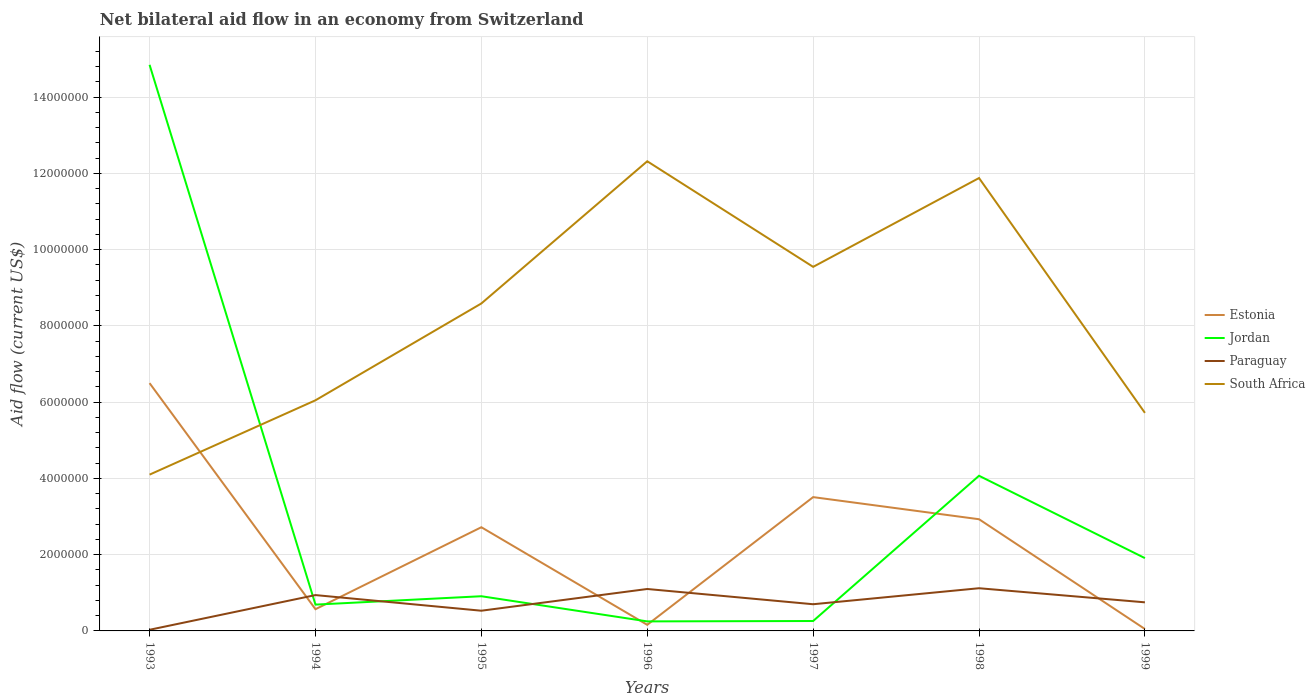Across all years, what is the maximum net bilateral aid flow in South Africa?
Ensure brevity in your answer.  4.10e+06. In which year was the net bilateral aid flow in South Africa maximum?
Give a very brief answer. 1993. What is the difference between the highest and the second highest net bilateral aid flow in Estonia?
Keep it short and to the point. 6.45e+06. What is the difference between the highest and the lowest net bilateral aid flow in Estonia?
Provide a succinct answer. 4. Is the net bilateral aid flow in Jordan strictly greater than the net bilateral aid flow in South Africa over the years?
Your answer should be compact. No. Are the values on the major ticks of Y-axis written in scientific E-notation?
Your answer should be very brief. No. Where does the legend appear in the graph?
Your answer should be very brief. Center right. How many legend labels are there?
Provide a succinct answer. 4. How are the legend labels stacked?
Ensure brevity in your answer.  Vertical. What is the title of the graph?
Keep it short and to the point. Net bilateral aid flow in an economy from Switzerland. Does "Yemen, Rep." appear as one of the legend labels in the graph?
Offer a terse response. No. What is the label or title of the X-axis?
Provide a succinct answer. Years. What is the Aid flow (current US$) in Estonia in 1993?
Your answer should be very brief. 6.50e+06. What is the Aid flow (current US$) of Jordan in 1993?
Your answer should be compact. 1.48e+07. What is the Aid flow (current US$) in Paraguay in 1993?
Ensure brevity in your answer.  3.00e+04. What is the Aid flow (current US$) of South Africa in 1993?
Offer a terse response. 4.10e+06. What is the Aid flow (current US$) in Estonia in 1994?
Make the answer very short. 5.70e+05. What is the Aid flow (current US$) in Jordan in 1994?
Your answer should be very brief. 6.90e+05. What is the Aid flow (current US$) in Paraguay in 1994?
Make the answer very short. 9.40e+05. What is the Aid flow (current US$) of South Africa in 1994?
Offer a terse response. 6.05e+06. What is the Aid flow (current US$) of Estonia in 1995?
Provide a succinct answer. 2.72e+06. What is the Aid flow (current US$) in Jordan in 1995?
Provide a short and direct response. 9.10e+05. What is the Aid flow (current US$) in Paraguay in 1995?
Offer a very short reply. 5.30e+05. What is the Aid flow (current US$) of South Africa in 1995?
Offer a very short reply. 8.59e+06. What is the Aid flow (current US$) in Jordan in 1996?
Keep it short and to the point. 2.50e+05. What is the Aid flow (current US$) in Paraguay in 1996?
Keep it short and to the point. 1.10e+06. What is the Aid flow (current US$) of South Africa in 1996?
Keep it short and to the point. 1.23e+07. What is the Aid flow (current US$) of Estonia in 1997?
Offer a very short reply. 3.51e+06. What is the Aid flow (current US$) in Jordan in 1997?
Provide a succinct answer. 2.60e+05. What is the Aid flow (current US$) of South Africa in 1997?
Offer a terse response. 9.55e+06. What is the Aid flow (current US$) in Estonia in 1998?
Give a very brief answer. 2.93e+06. What is the Aid flow (current US$) of Jordan in 1998?
Offer a terse response. 4.07e+06. What is the Aid flow (current US$) in Paraguay in 1998?
Your response must be concise. 1.12e+06. What is the Aid flow (current US$) of South Africa in 1998?
Offer a very short reply. 1.19e+07. What is the Aid flow (current US$) in Jordan in 1999?
Keep it short and to the point. 1.91e+06. What is the Aid flow (current US$) of Paraguay in 1999?
Keep it short and to the point. 7.50e+05. What is the Aid flow (current US$) in South Africa in 1999?
Give a very brief answer. 5.72e+06. Across all years, what is the maximum Aid flow (current US$) of Estonia?
Your answer should be very brief. 6.50e+06. Across all years, what is the maximum Aid flow (current US$) of Jordan?
Your response must be concise. 1.48e+07. Across all years, what is the maximum Aid flow (current US$) of Paraguay?
Give a very brief answer. 1.12e+06. Across all years, what is the maximum Aid flow (current US$) of South Africa?
Offer a terse response. 1.23e+07. Across all years, what is the minimum Aid flow (current US$) in Estonia?
Provide a short and direct response. 5.00e+04. Across all years, what is the minimum Aid flow (current US$) in Jordan?
Provide a short and direct response. 2.50e+05. Across all years, what is the minimum Aid flow (current US$) of South Africa?
Your response must be concise. 4.10e+06. What is the total Aid flow (current US$) of Estonia in the graph?
Offer a terse response. 1.64e+07. What is the total Aid flow (current US$) of Jordan in the graph?
Offer a very short reply. 2.29e+07. What is the total Aid flow (current US$) in Paraguay in the graph?
Provide a short and direct response. 5.17e+06. What is the total Aid flow (current US$) in South Africa in the graph?
Ensure brevity in your answer.  5.82e+07. What is the difference between the Aid flow (current US$) of Estonia in 1993 and that in 1994?
Provide a succinct answer. 5.93e+06. What is the difference between the Aid flow (current US$) of Jordan in 1993 and that in 1994?
Offer a very short reply. 1.42e+07. What is the difference between the Aid flow (current US$) of Paraguay in 1993 and that in 1994?
Your answer should be very brief. -9.10e+05. What is the difference between the Aid flow (current US$) in South Africa in 1993 and that in 1994?
Ensure brevity in your answer.  -1.95e+06. What is the difference between the Aid flow (current US$) in Estonia in 1993 and that in 1995?
Make the answer very short. 3.78e+06. What is the difference between the Aid flow (current US$) of Jordan in 1993 and that in 1995?
Your answer should be compact. 1.39e+07. What is the difference between the Aid flow (current US$) in Paraguay in 1993 and that in 1995?
Ensure brevity in your answer.  -5.00e+05. What is the difference between the Aid flow (current US$) in South Africa in 1993 and that in 1995?
Ensure brevity in your answer.  -4.49e+06. What is the difference between the Aid flow (current US$) of Estonia in 1993 and that in 1996?
Give a very brief answer. 6.34e+06. What is the difference between the Aid flow (current US$) in Jordan in 1993 and that in 1996?
Provide a succinct answer. 1.46e+07. What is the difference between the Aid flow (current US$) of Paraguay in 1993 and that in 1996?
Keep it short and to the point. -1.07e+06. What is the difference between the Aid flow (current US$) of South Africa in 1993 and that in 1996?
Provide a succinct answer. -8.22e+06. What is the difference between the Aid flow (current US$) in Estonia in 1993 and that in 1997?
Your answer should be compact. 2.99e+06. What is the difference between the Aid flow (current US$) of Jordan in 1993 and that in 1997?
Your answer should be compact. 1.46e+07. What is the difference between the Aid flow (current US$) in Paraguay in 1993 and that in 1997?
Your answer should be compact. -6.70e+05. What is the difference between the Aid flow (current US$) in South Africa in 1993 and that in 1997?
Ensure brevity in your answer.  -5.45e+06. What is the difference between the Aid flow (current US$) in Estonia in 1993 and that in 1998?
Offer a very short reply. 3.57e+06. What is the difference between the Aid flow (current US$) of Jordan in 1993 and that in 1998?
Your response must be concise. 1.08e+07. What is the difference between the Aid flow (current US$) in Paraguay in 1993 and that in 1998?
Provide a short and direct response. -1.09e+06. What is the difference between the Aid flow (current US$) of South Africa in 1993 and that in 1998?
Your answer should be very brief. -7.78e+06. What is the difference between the Aid flow (current US$) of Estonia in 1993 and that in 1999?
Keep it short and to the point. 6.45e+06. What is the difference between the Aid flow (current US$) of Jordan in 1993 and that in 1999?
Provide a short and direct response. 1.29e+07. What is the difference between the Aid flow (current US$) of Paraguay in 1993 and that in 1999?
Keep it short and to the point. -7.20e+05. What is the difference between the Aid flow (current US$) in South Africa in 1993 and that in 1999?
Make the answer very short. -1.62e+06. What is the difference between the Aid flow (current US$) of Estonia in 1994 and that in 1995?
Make the answer very short. -2.15e+06. What is the difference between the Aid flow (current US$) in Jordan in 1994 and that in 1995?
Your answer should be very brief. -2.20e+05. What is the difference between the Aid flow (current US$) of Paraguay in 1994 and that in 1995?
Your answer should be compact. 4.10e+05. What is the difference between the Aid flow (current US$) in South Africa in 1994 and that in 1995?
Your response must be concise. -2.54e+06. What is the difference between the Aid flow (current US$) of Estonia in 1994 and that in 1996?
Offer a very short reply. 4.10e+05. What is the difference between the Aid flow (current US$) in Paraguay in 1994 and that in 1996?
Provide a short and direct response. -1.60e+05. What is the difference between the Aid flow (current US$) of South Africa in 1994 and that in 1996?
Your answer should be compact. -6.27e+06. What is the difference between the Aid flow (current US$) in Estonia in 1994 and that in 1997?
Give a very brief answer. -2.94e+06. What is the difference between the Aid flow (current US$) of Paraguay in 1994 and that in 1997?
Give a very brief answer. 2.40e+05. What is the difference between the Aid flow (current US$) in South Africa in 1994 and that in 1997?
Ensure brevity in your answer.  -3.50e+06. What is the difference between the Aid flow (current US$) of Estonia in 1994 and that in 1998?
Give a very brief answer. -2.36e+06. What is the difference between the Aid flow (current US$) of Jordan in 1994 and that in 1998?
Your response must be concise. -3.38e+06. What is the difference between the Aid flow (current US$) in Paraguay in 1994 and that in 1998?
Your answer should be very brief. -1.80e+05. What is the difference between the Aid flow (current US$) in South Africa in 1994 and that in 1998?
Offer a very short reply. -5.83e+06. What is the difference between the Aid flow (current US$) of Estonia in 1994 and that in 1999?
Offer a very short reply. 5.20e+05. What is the difference between the Aid flow (current US$) in Jordan in 1994 and that in 1999?
Give a very brief answer. -1.22e+06. What is the difference between the Aid flow (current US$) of Paraguay in 1994 and that in 1999?
Offer a terse response. 1.90e+05. What is the difference between the Aid flow (current US$) in Estonia in 1995 and that in 1996?
Your response must be concise. 2.56e+06. What is the difference between the Aid flow (current US$) of Paraguay in 1995 and that in 1996?
Your answer should be very brief. -5.70e+05. What is the difference between the Aid flow (current US$) of South Africa in 1995 and that in 1996?
Your answer should be very brief. -3.73e+06. What is the difference between the Aid flow (current US$) in Estonia in 1995 and that in 1997?
Offer a terse response. -7.90e+05. What is the difference between the Aid flow (current US$) in Jordan in 1995 and that in 1997?
Give a very brief answer. 6.50e+05. What is the difference between the Aid flow (current US$) in South Africa in 1995 and that in 1997?
Offer a terse response. -9.60e+05. What is the difference between the Aid flow (current US$) of Jordan in 1995 and that in 1998?
Your response must be concise. -3.16e+06. What is the difference between the Aid flow (current US$) of Paraguay in 1995 and that in 1998?
Your response must be concise. -5.90e+05. What is the difference between the Aid flow (current US$) of South Africa in 1995 and that in 1998?
Your answer should be very brief. -3.29e+06. What is the difference between the Aid flow (current US$) of Estonia in 1995 and that in 1999?
Provide a short and direct response. 2.67e+06. What is the difference between the Aid flow (current US$) of Jordan in 1995 and that in 1999?
Make the answer very short. -1.00e+06. What is the difference between the Aid flow (current US$) in Paraguay in 1995 and that in 1999?
Ensure brevity in your answer.  -2.20e+05. What is the difference between the Aid flow (current US$) in South Africa in 1995 and that in 1999?
Provide a short and direct response. 2.87e+06. What is the difference between the Aid flow (current US$) of Estonia in 1996 and that in 1997?
Your answer should be compact. -3.35e+06. What is the difference between the Aid flow (current US$) in Jordan in 1996 and that in 1997?
Your answer should be very brief. -10000. What is the difference between the Aid flow (current US$) in South Africa in 1996 and that in 1997?
Your answer should be compact. 2.77e+06. What is the difference between the Aid flow (current US$) of Estonia in 1996 and that in 1998?
Your answer should be compact. -2.77e+06. What is the difference between the Aid flow (current US$) of Jordan in 1996 and that in 1998?
Ensure brevity in your answer.  -3.82e+06. What is the difference between the Aid flow (current US$) in South Africa in 1996 and that in 1998?
Offer a very short reply. 4.40e+05. What is the difference between the Aid flow (current US$) in Estonia in 1996 and that in 1999?
Your answer should be very brief. 1.10e+05. What is the difference between the Aid flow (current US$) in Jordan in 1996 and that in 1999?
Ensure brevity in your answer.  -1.66e+06. What is the difference between the Aid flow (current US$) in Paraguay in 1996 and that in 1999?
Ensure brevity in your answer.  3.50e+05. What is the difference between the Aid flow (current US$) of South Africa in 1996 and that in 1999?
Make the answer very short. 6.60e+06. What is the difference between the Aid flow (current US$) in Estonia in 1997 and that in 1998?
Make the answer very short. 5.80e+05. What is the difference between the Aid flow (current US$) of Jordan in 1997 and that in 1998?
Provide a succinct answer. -3.81e+06. What is the difference between the Aid flow (current US$) of Paraguay in 1997 and that in 1998?
Give a very brief answer. -4.20e+05. What is the difference between the Aid flow (current US$) of South Africa in 1997 and that in 1998?
Give a very brief answer. -2.33e+06. What is the difference between the Aid flow (current US$) in Estonia in 1997 and that in 1999?
Offer a very short reply. 3.46e+06. What is the difference between the Aid flow (current US$) of Jordan in 1997 and that in 1999?
Your answer should be compact. -1.65e+06. What is the difference between the Aid flow (current US$) of South Africa in 1997 and that in 1999?
Ensure brevity in your answer.  3.83e+06. What is the difference between the Aid flow (current US$) of Estonia in 1998 and that in 1999?
Your answer should be compact. 2.88e+06. What is the difference between the Aid flow (current US$) in Jordan in 1998 and that in 1999?
Make the answer very short. 2.16e+06. What is the difference between the Aid flow (current US$) of Paraguay in 1998 and that in 1999?
Offer a very short reply. 3.70e+05. What is the difference between the Aid flow (current US$) of South Africa in 1998 and that in 1999?
Make the answer very short. 6.16e+06. What is the difference between the Aid flow (current US$) of Estonia in 1993 and the Aid flow (current US$) of Jordan in 1994?
Offer a very short reply. 5.81e+06. What is the difference between the Aid flow (current US$) of Estonia in 1993 and the Aid flow (current US$) of Paraguay in 1994?
Your answer should be very brief. 5.56e+06. What is the difference between the Aid flow (current US$) in Jordan in 1993 and the Aid flow (current US$) in Paraguay in 1994?
Your response must be concise. 1.39e+07. What is the difference between the Aid flow (current US$) in Jordan in 1993 and the Aid flow (current US$) in South Africa in 1994?
Your answer should be very brief. 8.80e+06. What is the difference between the Aid flow (current US$) of Paraguay in 1993 and the Aid flow (current US$) of South Africa in 1994?
Your response must be concise. -6.02e+06. What is the difference between the Aid flow (current US$) in Estonia in 1993 and the Aid flow (current US$) in Jordan in 1995?
Ensure brevity in your answer.  5.59e+06. What is the difference between the Aid flow (current US$) in Estonia in 1993 and the Aid flow (current US$) in Paraguay in 1995?
Give a very brief answer. 5.97e+06. What is the difference between the Aid flow (current US$) of Estonia in 1993 and the Aid flow (current US$) of South Africa in 1995?
Your response must be concise. -2.09e+06. What is the difference between the Aid flow (current US$) of Jordan in 1993 and the Aid flow (current US$) of Paraguay in 1995?
Your answer should be very brief. 1.43e+07. What is the difference between the Aid flow (current US$) of Jordan in 1993 and the Aid flow (current US$) of South Africa in 1995?
Your response must be concise. 6.26e+06. What is the difference between the Aid flow (current US$) of Paraguay in 1993 and the Aid flow (current US$) of South Africa in 1995?
Keep it short and to the point. -8.56e+06. What is the difference between the Aid flow (current US$) of Estonia in 1993 and the Aid flow (current US$) of Jordan in 1996?
Ensure brevity in your answer.  6.25e+06. What is the difference between the Aid flow (current US$) in Estonia in 1993 and the Aid flow (current US$) in Paraguay in 1996?
Ensure brevity in your answer.  5.40e+06. What is the difference between the Aid flow (current US$) in Estonia in 1993 and the Aid flow (current US$) in South Africa in 1996?
Keep it short and to the point. -5.82e+06. What is the difference between the Aid flow (current US$) of Jordan in 1993 and the Aid flow (current US$) of Paraguay in 1996?
Provide a short and direct response. 1.38e+07. What is the difference between the Aid flow (current US$) of Jordan in 1993 and the Aid flow (current US$) of South Africa in 1996?
Ensure brevity in your answer.  2.53e+06. What is the difference between the Aid flow (current US$) in Paraguay in 1993 and the Aid flow (current US$) in South Africa in 1996?
Keep it short and to the point. -1.23e+07. What is the difference between the Aid flow (current US$) of Estonia in 1993 and the Aid flow (current US$) of Jordan in 1997?
Give a very brief answer. 6.24e+06. What is the difference between the Aid flow (current US$) in Estonia in 1993 and the Aid flow (current US$) in Paraguay in 1997?
Offer a terse response. 5.80e+06. What is the difference between the Aid flow (current US$) in Estonia in 1993 and the Aid flow (current US$) in South Africa in 1997?
Provide a short and direct response. -3.05e+06. What is the difference between the Aid flow (current US$) in Jordan in 1993 and the Aid flow (current US$) in Paraguay in 1997?
Offer a very short reply. 1.42e+07. What is the difference between the Aid flow (current US$) of Jordan in 1993 and the Aid flow (current US$) of South Africa in 1997?
Make the answer very short. 5.30e+06. What is the difference between the Aid flow (current US$) in Paraguay in 1993 and the Aid flow (current US$) in South Africa in 1997?
Your answer should be very brief. -9.52e+06. What is the difference between the Aid flow (current US$) in Estonia in 1993 and the Aid flow (current US$) in Jordan in 1998?
Provide a succinct answer. 2.43e+06. What is the difference between the Aid flow (current US$) of Estonia in 1993 and the Aid flow (current US$) of Paraguay in 1998?
Make the answer very short. 5.38e+06. What is the difference between the Aid flow (current US$) of Estonia in 1993 and the Aid flow (current US$) of South Africa in 1998?
Your answer should be compact. -5.38e+06. What is the difference between the Aid flow (current US$) of Jordan in 1993 and the Aid flow (current US$) of Paraguay in 1998?
Offer a very short reply. 1.37e+07. What is the difference between the Aid flow (current US$) of Jordan in 1993 and the Aid flow (current US$) of South Africa in 1998?
Offer a terse response. 2.97e+06. What is the difference between the Aid flow (current US$) in Paraguay in 1993 and the Aid flow (current US$) in South Africa in 1998?
Ensure brevity in your answer.  -1.18e+07. What is the difference between the Aid flow (current US$) of Estonia in 1993 and the Aid flow (current US$) of Jordan in 1999?
Your answer should be compact. 4.59e+06. What is the difference between the Aid flow (current US$) of Estonia in 1993 and the Aid flow (current US$) of Paraguay in 1999?
Your answer should be very brief. 5.75e+06. What is the difference between the Aid flow (current US$) in Estonia in 1993 and the Aid flow (current US$) in South Africa in 1999?
Keep it short and to the point. 7.80e+05. What is the difference between the Aid flow (current US$) of Jordan in 1993 and the Aid flow (current US$) of Paraguay in 1999?
Your response must be concise. 1.41e+07. What is the difference between the Aid flow (current US$) of Jordan in 1993 and the Aid flow (current US$) of South Africa in 1999?
Your answer should be very brief. 9.13e+06. What is the difference between the Aid flow (current US$) in Paraguay in 1993 and the Aid flow (current US$) in South Africa in 1999?
Offer a very short reply. -5.69e+06. What is the difference between the Aid flow (current US$) of Estonia in 1994 and the Aid flow (current US$) of Jordan in 1995?
Offer a terse response. -3.40e+05. What is the difference between the Aid flow (current US$) in Estonia in 1994 and the Aid flow (current US$) in South Africa in 1995?
Offer a terse response. -8.02e+06. What is the difference between the Aid flow (current US$) in Jordan in 1994 and the Aid flow (current US$) in South Africa in 1995?
Ensure brevity in your answer.  -7.90e+06. What is the difference between the Aid flow (current US$) in Paraguay in 1994 and the Aid flow (current US$) in South Africa in 1995?
Provide a succinct answer. -7.65e+06. What is the difference between the Aid flow (current US$) in Estonia in 1994 and the Aid flow (current US$) in Paraguay in 1996?
Your answer should be compact. -5.30e+05. What is the difference between the Aid flow (current US$) of Estonia in 1994 and the Aid flow (current US$) of South Africa in 1996?
Give a very brief answer. -1.18e+07. What is the difference between the Aid flow (current US$) in Jordan in 1994 and the Aid flow (current US$) in Paraguay in 1996?
Give a very brief answer. -4.10e+05. What is the difference between the Aid flow (current US$) in Jordan in 1994 and the Aid flow (current US$) in South Africa in 1996?
Keep it short and to the point. -1.16e+07. What is the difference between the Aid flow (current US$) of Paraguay in 1994 and the Aid flow (current US$) of South Africa in 1996?
Provide a short and direct response. -1.14e+07. What is the difference between the Aid flow (current US$) in Estonia in 1994 and the Aid flow (current US$) in Jordan in 1997?
Your response must be concise. 3.10e+05. What is the difference between the Aid flow (current US$) in Estonia in 1994 and the Aid flow (current US$) in Paraguay in 1997?
Provide a succinct answer. -1.30e+05. What is the difference between the Aid flow (current US$) of Estonia in 1994 and the Aid flow (current US$) of South Africa in 1997?
Offer a terse response. -8.98e+06. What is the difference between the Aid flow (current US$) in Jordan in 1994 and the Aid flow (current US$) in Paraguay in 1997?
Offer a terse response. -10000. What is the difference between the Aid flow (current US$) of Jordan in 1994 and the Aid flow (current US$) of South Africa in 1997?
Ensure brevity in your answer.  -8.86e+06. What is the difference between the Aid flow (current US$) in Paraguay in 1994 and the Aid flow (current US$) in South Africa in 1997?
Provide a short and direct response. -8.61e+06. What is the difference between the Aid flow (current US$) in Estonia in 1994 and the Aid flow (current US$) in Jordan in 1998?
Keep it short and to the point. -3.50e+06. What is the difference between the Aid flow (current US$) of Estonia in 1994 and the Aid flow (current US$) of Paraguay in 1998?
Your answer should be very brief. -5.50e+05. What is the difference between the Aid flow (current US$) in Estonia in 1994 and the Aid flow (current US$) in South Africa in 1998?
Ensure brevity in your answer.  -1.13e+07. What is the difference between the Aid flow (current US$) in Jordan in 1994 and the Aid flow (current US$) in Paraguay in 1998?
Your answer should be compact. -4.30e+05. What is the difference between the Aid flow (current US$) in Jordan in 1994 and the Aid flow (current US$) in South Africa in 1998?
Keep it short and to the point. -1.12e+07. What is the difference between the Aid flow (current US$) of Paraguay in 1994 and the Aid flow (current US$) of South Africa in 1998?
Offer a very short reply. -1.09e+07. What is the difference between the Aid flow (current US$) in Estonia in 1994 and the Aid flow (current US$) in Jordan in 1999?
Give a very brief answer. -1.34e+06. What is the difference between the Aid flow (current US$) in Estonia in 1994 and the Aid flow (current US$) in South Africa in 1999?
Give a very brief answer. -5.15e+06. What is the difference between the Aid flow (current US$) in Jordan in 1994 and the Aid flow (current US$) in South Africa in 1999?
Provide a short and direct response. -5.03e+06. What is the difference between the Aid flow (current US$) in Paraguay in 1994 and the Aid flow (current US$) in South Africa in 1999?
Give a very brief answer. -4.78e+06. What is the difference between the Aid flow (current US$) in Estonia in 1995 and the Aid flow (current US$) in Jordan in 1996?
Your answer should be compact. 2.47e+06. What is the difference between the Aid flow (current US$) in Estonia in 1995 and the Aid flow (current US$) in Paraguay in 1996?
Make the answer very short. 1.62e+06. What is the difference between the Aid flow (current US$) of Estonia in 1995 and the Aid flow (current US$) of South Africa in 1996?
Ensure brevity in your answer.  -9.60e+06. What is the difference between the Aid flow (current US$) of Jordan in 1995 and the Aid flow (current US$) of Paraguay in 1996?
Your answer should be compact. -1.90e+05. What is the difference between the Aid flow (current US$) in Jordan in 1995 and the Aid flow (current US$) in South Africa in 1996?
Give a very brief answer. -1.14e+07. What is the difference between the Aid flow (current US$) of Paraguay in 1995 and the Aid flow (current US$) of South Africa in 1996?
Give a very brief answer. -1.18e+07. What is the difference between the Aid flow (current US$) of Estonia in 1995 and the Aid flow (current US$) of Jordan in 1997?
Offer a terse response. 2.46e+06. What is the difference between the Aid flow (current US$) of Estonia in 1995 and the Aid flow (current US$) of Paraguay in 1997?
Make the answer very short. 2.02e+06. What is the difference between the Aid flow (current US$) in Estonia in 1995 and the Aid flow (current US$) in South Africa in 1997?
Offer a terse response. -6.83e+06. What is the difference between the Aid flow (current US$) in Jordan in 1995 and the Aid flow (current US$) in South Africa in 1997?
Your answer should be compact. -8.64e+06. What is the difference between the Aid flow (current US$) in Paraguay in 1995 and the Aid flow (current US$) in South Africa in 1997?
Provide a succinct answer. -9.02e+06. What is the difference between the Aid flow (current US$) in Estonia in 1995 and the Aid flow (current US$) in Jordan in 1998?
Ensure brevity in your answer.  -1.35e+06. What is the difference between the Aid flow (current US$) of Estonia in 1995 and the Aid flow (current US$) of Paraguay in 1998?
Make the answer very short. 1.60e+06. What is the difference between the Aid flow (current US$) of Estonia in 1995 and the Aid flow (current US$) of South Africa in 1998?
Provide a short and direct response. -9.16e+06. What is the difference between the Aid flow (current US$) of Jordan in 1995 and the Aid flow (current US$) of Paraguay in 1998?
Ensure brevity in your answer.  -2.10e+05. What is the difference between the Aid flow (current US$) of Jordan in 1995 and the Aid flow (current US$) of South Africa in 1998?
Give a very brief answer. -1.10e+07. What is the difference between the Aid flow (current US$) in Paraguay in 1995 and the Aid flow (current US$) in South Africa in 1998?
Your response must be concise. -1.14e+07. What is the difference between the Aid flow (current US$) of Estonia in 1995 and the Aid flow (current US$) of Jordan in 1999?
Your answer should be very brief. 8.10e+05. What is the difference between the Aid flow (current US$) in Estonia in 1995 and the Aid flow (current US$) in Paraguay in 1999?
Offer a terse response. 1.97e+06. What is the difference between the Aid flow (current US$) of Jordan in 1995 and the Aid flow (current US$) of Paraguay in 1999?
Ensure brevity in your answer.  1.60e+05. What is the difference between the Aid flow (current US$) of Jordan in 1995 and the Aid flow (current US$) of South Africa in 1999?
Ensure brevity in your answer.  -4.81e+06. What is the difference between the Aid flow (current US$) in Paraguay in 1995 and the Aid flow (current US$) in South Africa in 1999?
Your answer should be very brief. -5.19e+06. What is the difference between the Aid flow (current US$) in Estonia in 1996 and the Aid flow (current US$) in Jordan in 1997?
Ensure brevity in your answer.  -1.00e+05. What is the difference between the Aid flow (current US$) of Estonia in 1996 and the Aid flow (current US$) of Paraguay in 1997?
Make the answer very short. -5.40e+05. What is the difference between the Aid flow (current US$) in Estonia in 1996 and the Aid flow (current US$) in South Africa in 1997?
Provide a short and direct response. -9.39e+06. What is the difference between the Aid flow (current US$) in Jordan in 1996 and the Aid flow (current US$) in Paraguay in 1997?
Offer a terse response. -4.50e+05. What is the difference between the Aid flow (current US$) of Jordan in 1996 and the Aid flow (current US$) of South Africa in 1997?
Give a very brief answer. -9.30e+06. What is the difference between the Aid flow (current US$) in Paraguay in 1996 and the Aid flow (current US$) in South Africa in 1997?
Provide a succinct answer. -8.45e+06. What is the difference between the Aid flow (current US$) of Estonia in 1996 and the Aid flow (current US$) of Jordan in 1998?
Offer a very short reply. -3.91e+06. What is the difference between the Aid flow (current US$) in Estonia in 1996 and the Aid flow (current US$) in Paraguay in 1998?
Keep it short and to the point. -9.60e+05. What is the difference between the Aid flow (current US$) of Estonia in 1996 and the Aid flow (current US$) of South Africa in 1998?
Make the answer very short. -1.17e+07. What is the difference between the Aid flow (current US$) in Jordan in 1996 and the Aid flow (current US$) in Paraguay in 1998?
Your answer should be very brief. -8.70e+05. What is the difference between the Aid flow (current US$) of Jordan in 1996 and the Aid flow (current US$) of South Africa in 1998?
Keep it short and to the point. -1.16e+07. What is the difference between the Aid flow (current US$) of Paraguay in 1996 and the Aid flow (current US$) of South Africa in 1998?
Keep it short and to the point. -1.08e+07. What is the difference between the Aid flow (current US$) of Estonia in 1996 and the Aid flow (current US$) of Jordan in 1999?
Your answer should be very brief. -1.75e+06. What is the difference between the Aid flow (current US$) in Estonia in 1996 and the Aid flow (current US$) in Paraguay in 1999?
Ensure brevity in your answer.  -5.90e+05. What is the difference between the Aid flow (current US$) in Estonia in 1996 and the Aid flow (current US$) in South Africa in 1999?
Keep it short and to the point. -5.56e+06. What is the difference between the Aid flow (current US$) in Jordan in 1996 and the Aid flow (current US$) in Paraguay in 1999?
Ensure brevity in your answer.  -5.00e+05. What is the difference between the Aid flow (current US$) in Jordan in 1996 and the Aid flow (current US$) in South Africa in 1999?
Provide a succinct answer. -5.47e+06. What is the difference between the Aid flow (current US$) of Paraguay in 1996 and the Aid flow (current US$) of South Africa in 1999?
Provide a short and direct response. -4.62e+06. What is the difference between the Aid flow (current US$) in Estonia in 1997 and the Aid flow (current US$) in Jordan in 1998?
Keep it short and to the point. -5.60e+05. What is the difference between the Aid flow (current US$) in Estonia in 1997 and the Aid flow (current US$) in Paraguay in 1998?
Your answer should be very brief. 2.39e+06. What is the difference between the Aid flow (current US$) of Estonia in 1997 and the Aid flow (current US$) of South Africa in 1998?
Your answer should be very brief. -8.37e+06. What is the difference between the Aid flow (current US$) of Jordan in 1997 and the Aid flow (current US$) of Paraguay in 1998?
Make the answer very short. -8.60e+05. What is the difference between the Aid flow (current US$) in Jordan in 1997 and the Aid flow (current US$) in South Africa in 1998?
Your answer should be compact. -1.16e+07. What is the difference between the Aid flow (current US$) of Paraguay in 1997 and the Aid flow (current US$) of South Africa in 1998?
Give a very brief answer. -1.12e+07. What is the difference between the Aid flow (current US$) in Estonia in 1997 and the Aid flow (current US$) in Jordan in 1999?
Give a very brief answer. 1.60e+06. What is the difference between the Aid flow (current US$) in Estonia in 1997 and the Aid flow (current US$) in Paraguay in 1999?
Give a very brief answer. 2.76e+06. What is the difference between the Aid flow (current US$) of Estonia in 1997 and the Aid flow (current US$) of South Africa in 1999?
Provide a short and direct response. -2.21e+06. What is the difference between the Aid flow (current US$) in Jordan in 1997 and the Aid flow (current US$) in Paraguay in 1999?
Make the answer very short. -4.90e+05. What is the difference between the Aid flow (current US$) in Jordan in 1997 and the Aid flow (current US$) in South Africa in 1999?
Offer a terse response. -5.46e+06. What is the difference between the Aid flow (current US$) in Paraguay in 1997 and the Aid flow (current US$) in South Africa in 1999?
Your answer should be very brief. -5.02e+06. What is the difference between the Aid flow (current US$) in Estonia in 1998 and the Aid flow (current US$) in Jordan in 1999?
Make the answer very short. 1.02e+06. What is the difference between the Aid flow (current US$) in Estonia in 1998 and the Aid flow (current US$) in Paraguay in 1999?
Provide a succinct answer. 2.18e+06. What is the difference between the Aid flow (current US$) in Estonia in 1998 and the Aid flow (current US$) in South Africa in 1999?
Provide a succinct answer. -2.79e+06. What is the difference between the Aid flow (current US$) in Jordan in 1998 and the Aid flow (current US$) in Paraguay in 1999?
Make the answer very short. 3.32e+06. What is the difference between the Aid flow (current US$) in Jordan in 1998 and the Aid flow (current US$) in South Africa in 1999?
Give a very brief answer. -1.65e+06. What is the difference between the Aid flow (current US$) in Paraguay in 1998 and the Aid flow (current US$) in South Africa in 1999?
Offer a terse response. -4.60e+06. What is the average Aid flow (current US$) in Estonia per year?
Provide a succinct answer. 2.35e+06. What is the average Aid flow (current US$) of Jordan per year?
Your answer should be compact. 3.28e+06. What is the average Aid flow (current US$) in Paraguay per year?
Offer a very short reply. 7.39e+05. What is the average Aid flow (current US$) of South Africa per year?
Your answer should be very brief. 8.32e+06. In the year 1993, what is the difference between the Aid flow (current US$) in Estonia and Aid flow (current US$) in Jordan?
Offer a terse response. -8.35e+06. In the year 1993, what is the difference between the Aid flow (current US$) in Estonia and Aid flow (current US$) in Paraguay?
Your answer should be very brief. 6.47e+06. In the year 1993, what is the difference between the Aid flow (current US$) of Estonia and Aid flow (current US$) of South Africa?
Your response must be concise. 2.40e+06. In the year 1993, what is the difference between the Aid flow (current US$) of Jordan and Aid flow (current US$) of Paraguay?
Provide a succinct answer. 1.48e+07. In the year 1993, what is the difference between the Aid flow (current US$) of Jordan and Aid flow (current US$) of South Africa?
Provide a short and direct response. 1.08e+07. In the year 1993, what is the difference between the Aid flow (current US$) of Paraguay and Aid flow (current US$) of South Africa?
Make the answer very short. -4.07e+06. In the year 1994, what is the difference between the Aid flow (current US$) of Estonia and Aid flow (current US$) of Paraguay?
Provide a short and direct response. -3.70e+05. In the year 1994, what is the difference between the Aid flow (current US$) in Estonia and Aid flow (current US$) in South Africa?
Your response must be concise. -5.48e+06. In the year 1994, what is the difference between the Aid flow (current US$) of Jordan and Aid flow (current US$) of South Africa?
Your response must be concise. -5.36e+06. In the year 1994, what is the difference between the Aid flow (current US$) of Paraguay and Aid flow (current US$) of South Africa?
Offer a very short reply. -5.11e+06. In the year 1995, what is the difference between the Aid flow (current US$) in Estonia and Aid flow (current US$) in Jordan?
Keep it short and to the point. 1.81e+06. In the year 1995, what is the difference between the Aid flow (current US$) in Estonia and Aid flow (current US$) in Paraguay?
Ensure brevity in your answer.  2.19e+06. In the year 1995, what is the difference between the Aid flow (current US$) in Estonia and Aid flow (current US$) in South Africa?
Make the answer very short. -5.87e+06. In the year 1995, what is the difference between the Aid flow (current US$) in Jordan and Aid flow (current US$) in South Africa?
Ensure brevity in your answer.  -7.68e+06. In the year 1995, what is the difference between the Aid flow (current US$) of Paraguay and Aid flow (current US$) of South Africa?
Make the answer very short. -8.06e+06. In the year 1996, what is the difference between the Aid flow (current US$) in Estonia and Aid flow (current US$) in Jordan?
Give a very brief answer. -9.00e+04. In the year 1996, what is the difference between the Aid flow (current US$) in Estonia and Aid flow (current US$) in Paraguay?
Ensure brevity in your answer.  -9.40e+05. In the year 1996, what is the difference between the Aid flow (current US$) of Estonia and Aid flow (current US$) of South Africa?
Make the answer very short. -1.22e+07. In the year 1996, what is the difference between the Aid flow (current US$) in Jordan and Aid flow (current US$) in Paraguay?
Provide a short and direct response. -8.50e+05. In the year 1996, what is the difference between the Aid flow (current US$) in Jordan and Aid flow (current US$) in South Africa?
Give a very brief answer. -1.21e+07. In the year 1996, what is the difference between the Aid flow (current US$) of Paraguay and Aid flow (current US$) of South Africa?
Make the answer very short. -1.12e+07. In the year 1997, what is the difference between the Aid flow (current US$) in Estonia and Aid flow (current US$) in Jordan?
Provide a short and direct response. 3.25e+06. In the year 1997, what is the difference between the Aid flow (current US$) in Estonia and Aid flow (current US$) in Paraguay?
Offer a very short reply. 2.81e+06. In the year 1997, what is the difference between the Aid flow (current US$) in Estonia and Aid flow (current US$) in South Africa?
Make the answer very short. -6.04e+06. In the year 1997, what is the difference between the Aid flow (current US$) of Jordan and Aid flow (current US$) of Paraguay?
Make the answer very short. -4.40e+05. In the year 1997, what is the difference between the Aid flow (current US$) in Jordan and Aid flow (current US$) in South Africa?
Your response must be concise. -9.29e+06. In the year 1997, what is the difference between the Aid flow (current US$) in Paraguay and Aid flow (current US$) in South Africa?
Provide a short and direct response. -8.85e+06. In the year 1998, what is the difference between the Aid flow (current US$) in Estonia and Aid flow (current US$) in Jordan?
Offer a terse response. -1.14e+06. In the year 1998, what is the difference between the Aid flow (current US$) in Estonia and Aid flow (current US$) in Paraguay?
Provide a succinct answer. 1.81e+06. In the year 1998, what is the difference between the Aid flow (current US$) in Estonia and Aid flow (current US$) in South Africa?
Provide a succinct answer. -8.95e+06. In the year 1998, what is the difference between the Aid flow (current US$) in Jordan and Aid flow (current US$) in Paraguay?
Provide a short and direct response. 2.95e+06. In the year 1998, what is the difference between the Aid flow (current US$) in Jordan and Aid flow (current US$) in South Africa?
Offer a terse response. -7.81e+06. In the year 1998, what is the difference between the Aid flow (current US$) in Paraguay and Aid flow (current US$) in South Africa?
Give a very brief answer. -1.08e+07. In the year 1999, what is the difference between the Aid flow (current US$) in Estonia and Aid flow (current US$) in Jordan?
Make the answer very short. -1.86e+06. In the year 1999, what is the difference between the Aid flow (current US$) of Estonia and Aid flow (current US$) of Paraguay?
Provide a succinct answer. -7.00e+05. In the year 1999, what is the difference between the Aid flow (current US$) of Estonia and Aid flow (current US$) of South Africa?
Offer a very short reply. -5.67e+06. In the year 1999, what is the difference between the Aid flow (current US$) of Jordan and Aid flow (current US$) of Paraguay?
Offer a very short reply. 1.16e+06. In the year 1999, what is the difference between the Aid flow (current US$) in Jordan and Aid flow (current US$) in South Africa?
Offer a very short reply. -3.81e+06. In the year 1999, what is the difference between the Aid flow (current US$) of Paraguay and Aid flow (current US$) of South Africa?
Provide a succinct answer. -4.97e+06. What is the ratio of the Aid flow (current US$) in Estonia in 1993 to that in 1994?
Offer a very short reply. 11.4. What is the ratio of the Aid flow (current US$) in Jordan in 1993 to that in 1994?
Offer a very short reply. 21.52. What is the ratio of the Aid flow (current US$) in Paraguay in 1993 to that in 1994?
Give a very brief answer. 0.03. What is the ratio of the Aid flow (current US$) in South Africa in 1993 to that in 1994?
Make the answer very short. 0.68. What is the ratio of the Aid flow (current US$) of Estonia in 1993 to that in 1995?
Your response must be concise. 2.39. What is the ratio of the Aid flow (current US$) in Jordan in 1993 to that in 1995?
Provide a succinct answer. 16.32. What is the ratio of the Aid flow (current US$) in Paraguay in 1993 to that in 1995?
Your answer should be very brief. 0.06. What is the ratio of the Aid flow (current US$) in South Africa in 1993 to that in 1995?
Keep it short and to the point. 0.48. What is the ratio of the Aid flow (current US$) in Estonia in 1993 to that in 1996?
Keep it short and to the point. 40.62. What is the ratio of the Aid flow (current US$) in Jordan in 1993 to that in 1996?
Offer a terse response. 59.4. What is the ratio of the Aid flow (current US$) in Paraguay in 1993 to that in 1996?
Give a very brief answer. 0.03. What is the ratio of the Aid flow (current US$) of South Africa in 1993 to that in 1996?
Give a very brief answer. 0.33. What is the ratio of the Aid flow (current US$) of Estonia in 1993 to that in 1997?
Ensure brevity in your answer.  1.85. What is the ratio of the Aid flow (current US$) in Jordan in 1993 to that in 1997?
Give a very brief answer. 57.12. What is the ratio of the Aid flow (current US$) in Paraguay in 1993 to that in 1997?
Your answer should be compact. 0.04. What is the ratio of the Aid flow (current US$) in South Africa in 1993 to that in 1997?
Your answer should be compact. 0.43. What is the ratio of the Aid flow (current US$) of Estonia in 1993 to that in 1998?
Your answer should be compact. 2.22. What is the ratio of the Aid flow (current US$) in Jordan in 1993 to that in 1998?
Your answer should be compact. 3.65. What is the ratio of the Aid flow (current US$) in Paraguay in 1993 to that in 1998?
Your answer should be compact. 0.03. What is the ratio of the Aid flow (current US$) in South Africa in 1993 to that in 1998?
Your answer should be compact. 0.35. What is the ratio of the Aid flow (current US$) of Estonia in 1993 to that in 1999?
Ensure brevity in your answer.  130. What is the ratio of the Aid flow (current US$) in Jordan in 1993 to that in 1999?
Ensure brevity in your answer.  7.77. What is the ratio of the Aid flow (current US$) in Paraguay in 1993 to that in 1999?
Provide a succinct answer. 0.04. What is the ratio of the Aid flow (current US$) of South Africa in 1993 to that in 1999?
Offer a terse response. 0.72. What is the ratio of the Aid flow (current US$) in Estonia in 1994 to that in 1995?
Ensure brevity in your answer.  0.21. What is the ratio of the Aid flow (current US$) of Jordan in 1994 to that in 1995?
Your response must be concise. 0.76. What is the ratio of the Aid flow (current US$) of Paraguay in 1994 to that in 1995?
Your response must be concise. 1.77. What is the ratio of the Aid flow (current US$) in South Africa in 1994 to that in 1995?
Offer a very short reply. 0.7. What is the ratio of the Aid flow (current US$) in Estonia in 1994 to that in 1996?
Provide a succinct answer. 3.56. What is the ratio of the Aid flow (current US$) of Jordan in 1994 to that in 1996?
Provide a short and direct response. 2.76. What is the ratio of the Aid flow (current US$) in Paraguay in 1994 to that in 1996?
Make the answer very short. 0.85. What is the ratio of the Aid flow (current US$) in South Africa in 1994 to that in 1996?
Your answer should be very brief. 0.49. What is the ratio of the Aid flow (current US$) of Estonia in 1994 to that in 1997?
Provide a succinct answer. 0.16. What is the ratio of the Aid flow (current US$) in Jordan in 1994 to that in 1997?
Your answer should be compact. 2.65. What is the ratio of the Aid flow (current US$) in Paraguay in 1994 to that in 1997?
Provide a succinct answer. 1.34. What is the ratio of the Aid flow (current US$) of South Africa in 1994 to that in 1997?
Keep it short and to the point. 0.63. What is the ratio of the Aid flow (current US$) of Estonia in 1994 to that in 1998?
Give a very brief answer. 0.19. What is the ratio of the Aid flow (current US$) in Jordan in 1994 to that in 1998?
Offer a terse response. 0.17. What is the ratio of the Aid flow (current US$) in Paraguay in 1994 to that in 1998?
Offer a very short reply. 0.84. What is the ratio of the Aid flow (current US$) in South Africa in 1994 to that in 1998?
Provide a succinct answer. 0.51. What is the ratio of the Aid flow (current US$) of Estonia in 1994 to that in 1999?
Ensure brevity in your answer.  11.4. What is the ratio of the Aid flow (current US$) in Jordan in 1994 to that in 1999?
Offer a terse response. 0.36. What is the ratio of the Aid flow (current US$) in Paraguay in 1994 to that in 1999?
Keep it short and to the point. 1.25. What is the ratio of the Aid flow (current US$) in South Africa in 1994 to that in 1999?
Ensure brevity in your answer.  1.06. What is the ratio of the Aid flow (current US$) of Estonia in 1995 to that in 1996?
Offer a very short reply. 17. What is the ratio of the Aid flow (current US$) in Jordan in 1995 to that in 1996?
Give a very brief answer. 3.64. What is the ratio of the Aid flow (current US$) of Paraguay in 1995 to that in 1996?
Your answer should be compact. 0.48. What is the ratio of the Aid flow (current US$) of South Africa in 1995 to that in 1996?
Offer a very short reply. 0.7. What is the ratio of the Aid flow (current US$) of Estonia in 1995 to that in 1997?
Provide a succinct answer. 0.77. What is the ratio of the Aid flow (current US$) in Paraguay in 1995 to that in 1997?
Provide a short and direct response. 0.76. What is the ratio of the Aid flow (current US$) of South Africa in 1995 to that in 1997?
Keep it short and to the point. 0.9. What is the ratio of the Aid flow (current US$) in Estonia in 1995 to that in 1998?
Make the answer very short. 0.93. What is the ratio of the Aid flow (current US$) in Jordan in 1995 to that in 1998?
Offer a very short reply. 0.22. What is the ratio of the Aid flow (current US$) in Paraguay in 1995 to that in 1998?
Your answer should be very brief. 0.47. What is the ratio of the Aid flow (current US$) of South Africa in 1995 to that in 1998?
Give a very brief answer. 0.72. What is the ratio of the Aid flow (current US$) of Estonia in 1995 to that in 1999?
Make the answer very short. 54.4. What is the ratio of the Aid flow (current US$) of Jordan in 1995 to that in 1999?
Your response must be concise. 0.48. What is the ratio of the Aid flow (current US$) in Paraguay in 1995 to that in 1999?
Offer a very short reply. 0.71. What is the ratio of the Aid flow (current US$) of South Africa in 1995 to that in 1999?
Ensure brevity in your answer.  1.5. What is the ratio of the Aid flow (current US$) in Estonia in 1996 to that in 1997?
Offer a terse response. 0.05. What is the ratio of the Aid flow (current US$) in Jordan in 1996 to that in 1997?
Your response must be concise. 0.96. What is the ratio of the Aid flow (current US$) in Paraguay in 1996 to that in 1997?
Make the answer very short. 1.57. What is the ratio of the Aid flow (current US$) in South Africa in 1996 to that in 1997?
Offer a terse response. 1.29. What is the ratio of the Aid flow (current US$) in Estonia in 1996 to that in 1998?
Your answer should be very brief. 0.05. What is the ratio of the Aid flow (current US$) of Jordan in 1996 to that in 1998?
Ensure brevity in your answer.  0.06. What is the ratio of the Aid flow (current US$) in Paraguay in 1996 to that in 1998?
Ensure brevity in your answer.  0.98. What is the ratio of the Aid flow (current US$) of South Africa in 1996 to that in 1998?
Your answer should be compact. 1.04. What is the ratio of the Aid flow (current US$) of Estonia in 1996 to that in 1999?
Offer a very short reply. 3.2. What is the ratio of the Aid flow (current US$) of Jordan in 1996 to that in 1999?
Your response must be concise. 0.13. What is the ratio of the Aid flow (current US$) of Paraguay in 1996 to that in 1999?
Ensure brevity in your answer.  1.47. What is the ratio of the Aid flow (current US$) of South Africa in 1996 to that in 1999?
Offer a terse response. 2.15. What is the ratio of the Aid flow (current US$) in Estonia in 1997 to that in 1998?
Keep it short and to the point. 1.2. What is the ratio of the Aid flow (current US$) in Jordan in 1997 to that in 1998?
Give a very brief answer. 0.06. What is the ratio of the Aid flow (current US$) in South Africa in 1997 to that in 1998?
Offer a very short reply. 0.8. What is the ratio of the Aid flow (current US$) of Estonia in 1997 to that in 1999?
Give a very brief answer. 70.2. What is the ratio of the Aid flow (current US$) of Jordan in 1997 to that in 1999?
Provide a short and direct response. 0.14. What is the ratio of the Aid flow (current US$) in Paraguay in 1997 to that in 1999?
Make the answer very short. 0.93. What is the ratio of the Aid flow (current US$) of South Africa in 1997 to that in 1999?
Your response must be concise. 1.67. What is the ratio of the Aid flow (current US$) of Estonia in 1998 to that in 1999?
Your answer should be compact. 58.6. What is the ratio of the Aid flow (current US$) of Jordan in 1998 to that in 1999?
Offer a terse response. 2.13. What is the ratio of the Aid flow (current US$) in Paraguay in 1998 to that in 1999?
Your response must be concise. 1.49. What is the ratio of the Aid flow (current US$) of South Africa in 1998 to that in 1999?
Keep it short and to the point. 2.08. What is the difference between the highest and the second highest Aid flow (current US$) of Estonia?
Make the answer very short. 2.99e+06. What is the difference between the highest and the second highest Aid flow (current US$) in Jordan?
Provide a succinct answer. 1.08e+07. What is the difference between the highest and the second highest Aid flow (current US$) in Paraguay?
Your response must be concise. 2.00e+04. What is the difference between the highest and the lowest Aid flow (current US$) of Estonia?
Keep it short and to the point. 6.45e+06. What is the difference between the highest and the lowest Aid flow (current US$) of Jordan?
Give a very brief answer. 1.46e+07. What is the difference between the highest and the lowest Aid flow (current US$) in Paraguay?
Ensure brevity in your answer.  1.09e+06. What is the difference between the highest and the lowest Aid flow (current US$) of South Africa?
Give a very brief answer. 8.22e+06. 